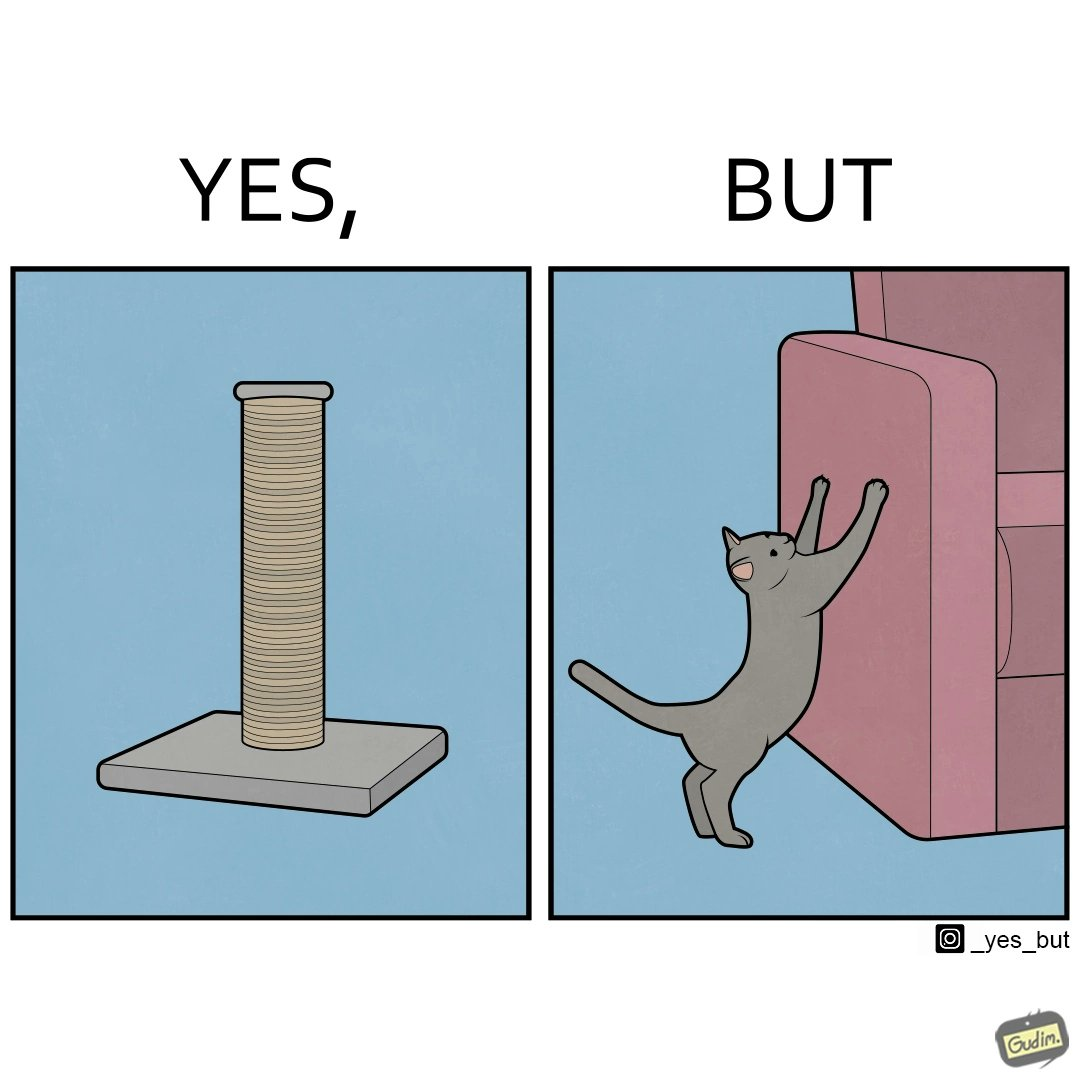What do you see in each half of this image? In the left part of the image: a cylindrical toy or some sort of thing  with a lots of rope wounded around its surface In the right part of the image: a cat scratching its nails over the sides of a sofa or trying to climb up the sofa 